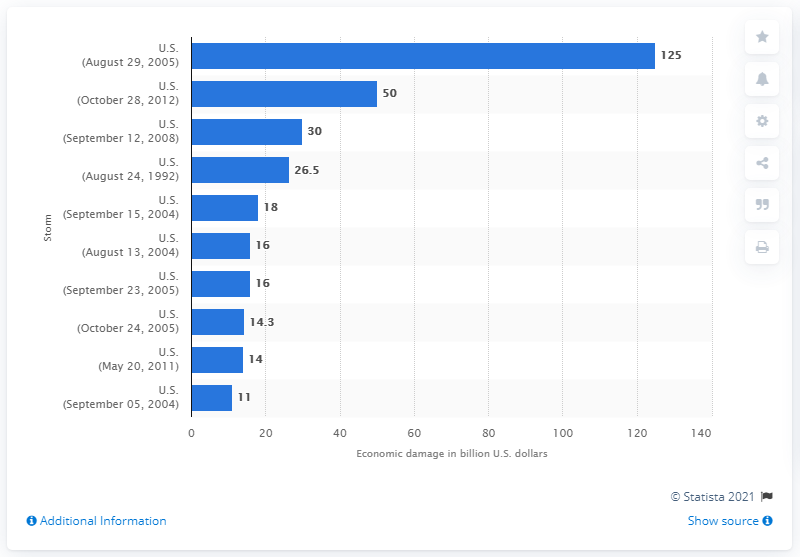Outline some significant characteristics in this image. The storm in the United States on August 29, 2005 caused an estimated $125 million in damages. 